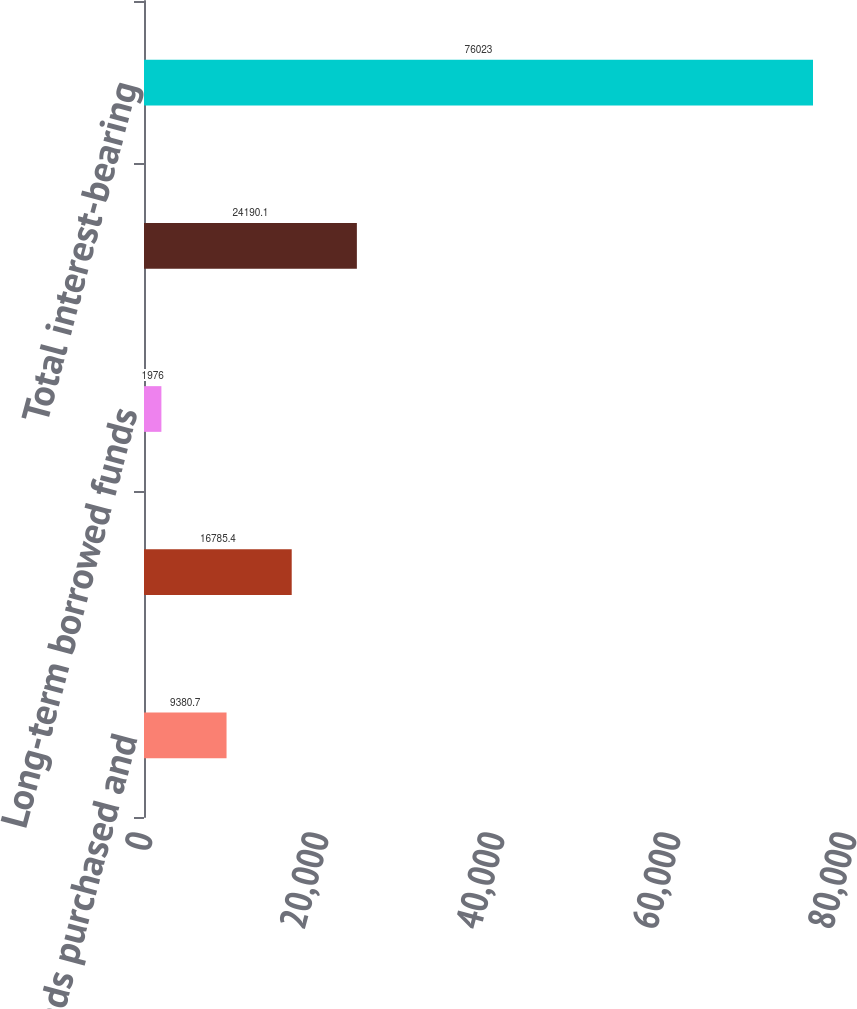Convert chart. <chart><loc_0><loc_0><loc_500><loc_500><bar_chart><fcel>Federal funds purchased and<fcel>Other short-term borrowed<fcel>Long-term borrowed funds<fcel>Total borrowed funds<fcel>Total interest-bearing<nl><fcel>9380.7<fcel>16785.4<fcel>1976<fcel>24190.1<fcel>76023<nl></chart> 